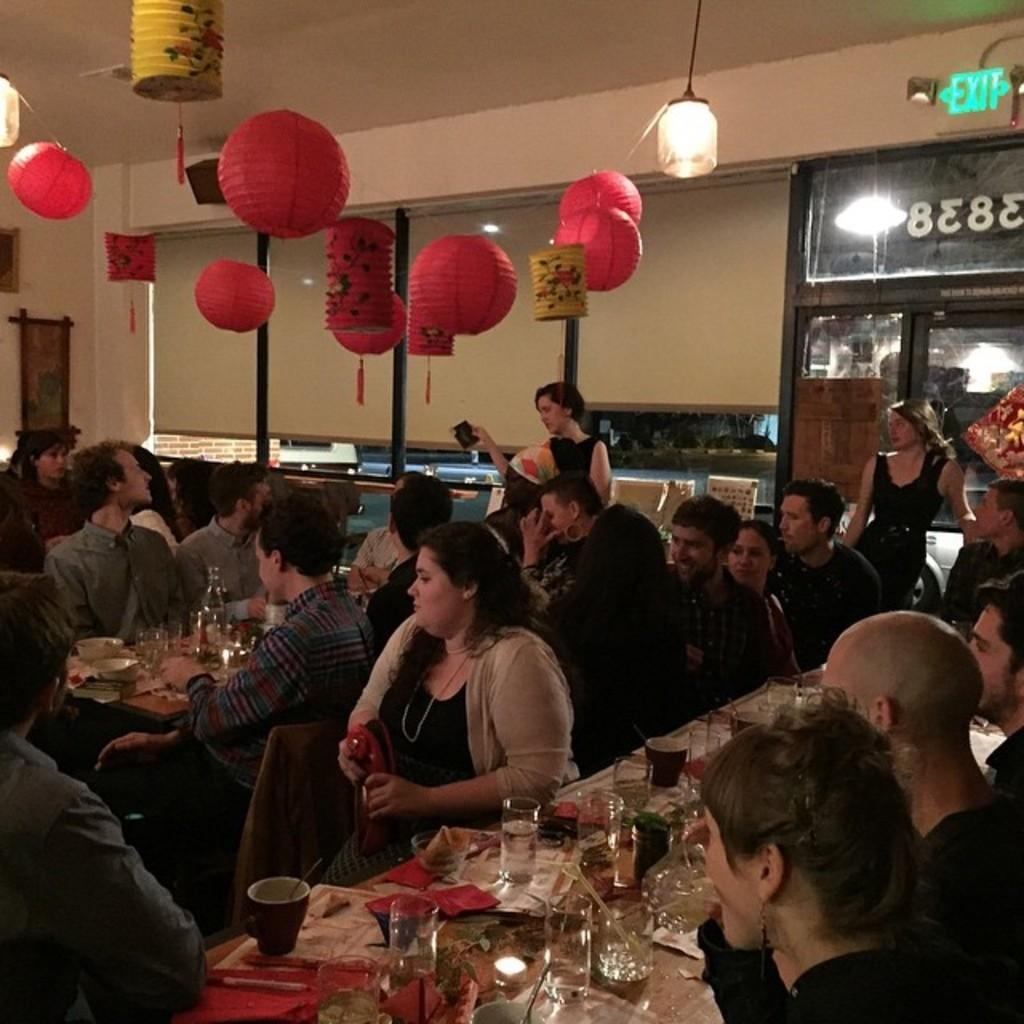What are the people in the image doing? There is a group of persons sitting on chairs in the image. What is in front of the chairs? There is a table in front of the chairs. What can be seen on the table? There is a glass on the table, and there are objects on the table as well. What type of lighting is present in the image? There is a lamp in the image. What architectural feature is visible in the image? There is a roof visible in the image. What type of bell can be heard ringing in the image? There is no bell present in the image, and therefore no sound can be heard. Can you describe the dog that is sitting next to the group of persons in the image? There is no dog present in the image; only the group of persons, chairs, table, glass, objects, lamp, and roof are visible. 